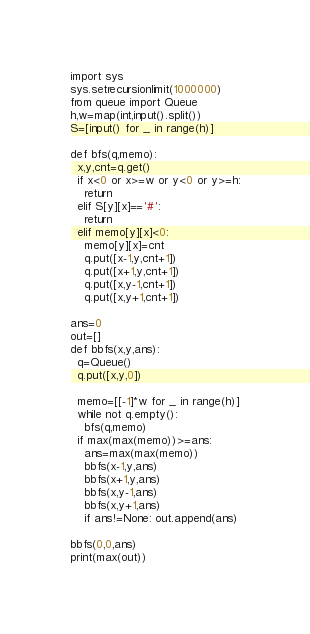Convert code to text. <code><loc_0><loc_0><loc_500><loc_500><_Python_>import sys
sys.setrecursionlimit(1000000)
from queue import Queue
h,w=map(int,input().split())
S=[input() for _ in range(h)]

def bfs(q,memo):
  x,y,cnt=q.get()
  if x<0 or x>=w or y<0 or y>=h:
    return
  elif S[y][x]=='#':
    return
  elif memo[y][x]<0:
    memo[y][x]=cnt
    q.put([x-1,y,cnt+1])
    q.put([x+1,y,cnt+1])
    q.put([x,y-1,cnt+1])
    q.put([x,y+1,cnt+1])
    
ans=0
out=[]
def bbfs(x,y,ans):
  q=Queue()
  q.put([x,y,0])

  memo=[[-1]*w for _ in range(h)]
  while not q.empty():
    bfs(q,memo)
  if max(max(memo))>=ans:
    ans=max(max(memo))
    bbfs(x-1,y,ans)
    bbfs(x+1,y,ans)
    bbfs(x,y-1,ans)
    bbfs(x,y+1,ans)
    if ans!=None: out.append(ans)
    
bbfs(0,0,ans)
print(max(out))</code> 